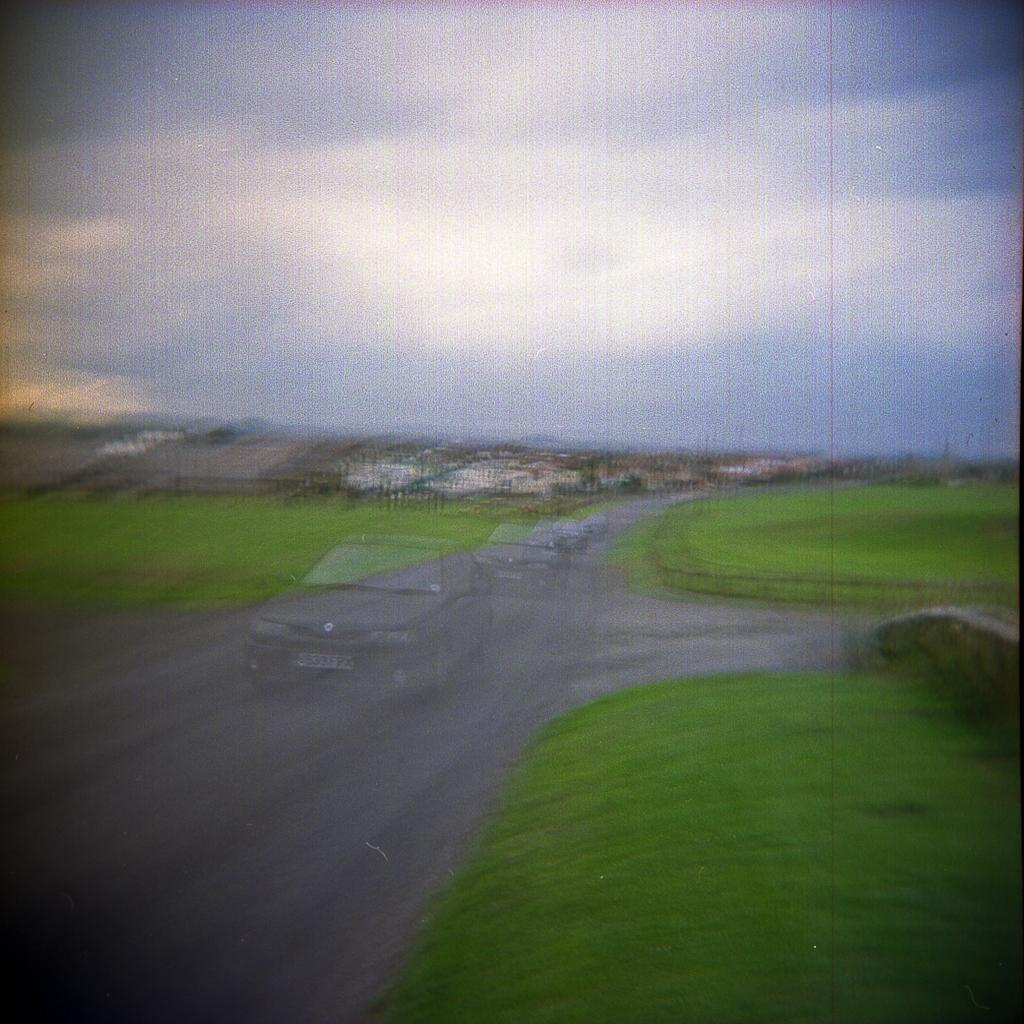What type of image is being described? The image is a graphic. What can be seen in the center of the image? There are vehicles on the road in the center of the image. What is visible in the background of the image? The sky, clouds, buildings, and grass are present in the background of the image. How many people are in the crowd in the image? There is no crowd present in the image; it features vehicles on a road with a background of sky, clouds, buildings, and grass. 